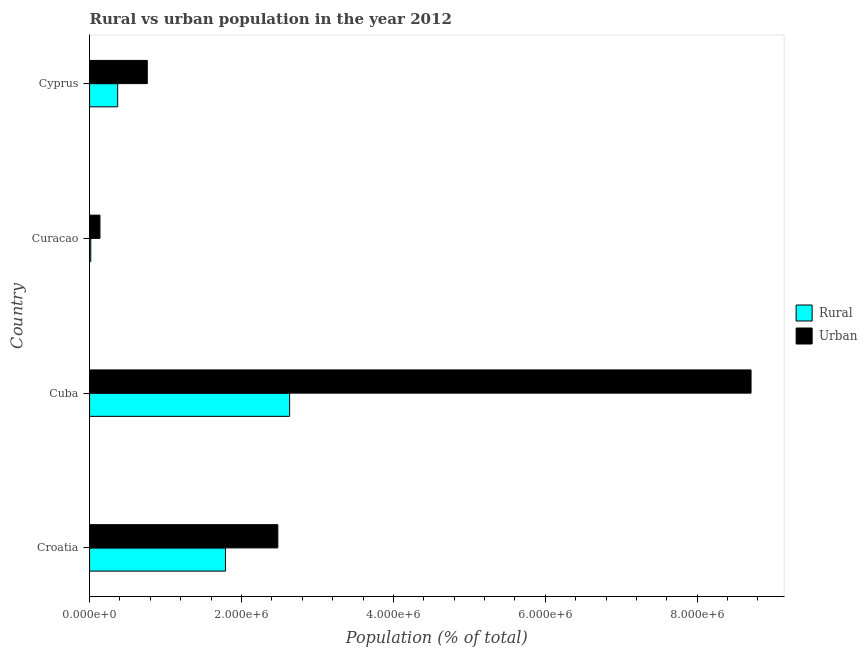Are the number of bars per tick equal to the number of legend labels?
Your response must be concise. Yes. How many bars are there on the 3rd tick from the bottom?
Give a very brief answer. 2. What is the label of the 4th group of bars from the top?
Provide a short and direct response. Croatia. In how many cases, is the number of bars for a given country not equal to the number of legend labels?
Make the answer very short. 0. What is the rural population density in Croatia?
Your answer should be compact. 1.79e+06. Across all countries, what is the maximum urban population density?
Keep it short and to the point. 8.71e+06. Across all countries, what is the minimum rural population density?
Give a very brief answer. 1.57e+04. In which country was the urban population density maximum?
Provide a succinct answer. Cuba. In which country was the rural population density minimum?
Provide a short and direct response. Curacao. What is the total rural population density in the graph?
Your response must be concise. 4.81e+06. What is the difference between the rural population density in Cuba and that in Cyprus?
Provide a short and direct response. 2.26e+06. What is the difference between the rural population density in Croatia and the urban population density in Cyprus?
Your answer should be compact. 1.03e+06. What is the average urban population density per country?
Your answer should be very brief. 3.02e+06. What is the difference between the rural population density and urban population density in Curacao?
Your answer should be compact. -1.21e+05. In how many countries, is the urban population density greater than 3600000 %?
Your response must be concise. 1. What is the ratio of the urban population density in Croatia to that in Cuba?
Make the answer very short. 0.28. What is the difference between the highest and the second highest rural population density?
Your response must be concise. 8.44e+05. What is the difference between the highest and the lowest rural population density?
Provide a succinct answer. 2.62e+06. In how many countries, is the urban population density greater than the average urban population density taken over all countries?
Offer a terse response. 1. Is the sum of the rural population density in Croatia and Cyprus greater than the maximum urban population density across all countries?
Make the answer very short. No. What does the 2nd bar from the top in Croatia represents?
Provide a short and direct response. Rural. What does the 2nd bar from the bottom in Cyprus represents?
Ensure brevity in your answer.  Urban. What is the difference between two consecutive major ticks on the X-axis?
Keep it short and to the point. 2.00e+06. Are the values on the major ticks of X-axis written in scientific E-notation?
Offer a terse response. Yes. Does the graph contain any zero values?
Your response must be concise. No. Does the graph contain grids?
Make the answer very short. No. Where does the legend appear in the graph?
Provide a short and direct response. Center right. What is the title of the graph?
Provide a short and direct response. Rural vs urban population in the year 2012. Does "Primary education" appear as one of the legend labels in the graph?
Provide a succinct answer. No. What is the label or title of the X-axis?
Give a very brief answer. Population (% of total). What is the label or title of the Y-axis?
Ensure brevity in your answer.  Country. What is the Population (% of total) in Rural in Croatia?
Give a very brief answer. 1.79e+06. What is the Population (% of total) in Urban in Croatia?
Provide a succinct answer. 2.48e+06. What is the Population (% of total) in Rural in Cuba?
Offer a very short reply. 2.63e+06. What is the Population (% of total) of Urban in Cuba?
Offer a terse response. 8.71e+06. What is the Population (% of total) of Rural in Curacao?
Provide a succinct answer. 1.57e+04. What is the Population (% of total) of Urban in Curacao?
Offer a very short reply. 1.36e+05. What is the Population (% of total) of Rural in Cyprus?
Provide a short and direct response. 3.70e+05. What is the Population (% of total) in Urban in Cyprus?
Ensure brevity in your answer.  7.60e+05. Across all countries, what is the maximum Population (% of total) of Rural?
Your response must be concise. 2.63e+06. Across all countries, what is the maximum Population (% of total) in Urban?
Make the answer very short. 8.71e+06. Across all countries, what is the minimum Population (% of total) in Rural?
Ensure brevity in your answer.  1.57e+04. Across all countries, what is the minimum Population (% of total) of Urban?
Keep it short and to the point. 1.36e+05. What is the total Population (% of total) of Rural in the graph?
Offer a very short reply. 4.81e+06. What is the total Population (% of total) of Urban in the graph?
Offer a terse response. 1.21e+07. What is the difference between the Population (% of total) in Rural in Croatia and that in Cuba?
Provide a short and direct response. -8.44e+05. What is the difference between the Population (% of total) in Urban in Croatia and that in Cuba?
Provide a short and direct response. -6.23e+06. What is the difference between the Population (% of total) of Rural in Croatia and that in Curacao?
Give a very brief answer. 1.77e+06. What is the difference between the Population (% of total) of Urban in Croatia and that in Curacao?
Give a very brief answer. 2.34e+06. What is the difference between the Population (% of total) in Rural in Croatia and that in Cyprus?
Your response must be concise. 1.42e+06. What is the difference between the Population (% of total) of Urban in Croatia and that in Cyprus?
Offer a terse response. 1.72e+06. What is the difference between the Population (% of total) in Rural in Cuba and that in Curacao?
Offer a terse response. 2.62e+06. What is the difference between the Population (% of total) of Urban in Cuba and that in Curacao?
Provide a short and direct response. 8.57e+06. What is the difference between the Population (% of total) of Rural in Cuba and that in Cyprus?
Give a very brief answer. 2.26e+06. What is the difference between the Population (% of total) in Urban in Cuba and that in Cyprus?
Keep it short and to the point. 7.95e+06. What is the difference between the Population (% of total) in Rural in Curacao and that in Cyprus?
Offer a terse response. -3.54e+05. What is the difference between the Population (% of total) of Urban in Curacao and that in Cyprus?
Your response must be concise. -6.23e+05. What is the difference between the Population (% of total) of Rural in Croatia and the Population (% of total) of Urban in Cuba?
Keep it short and to the point. -6.92e+06. What is the difference between the Population (% of total) in Rural in Croatia and the Population (% of total) in Urban in Curacao?
Make the answer very short. 1.65e+06. What is the difference between the Population (% of total) of Rural in Croatia and the Population (% of total) of Urban in Cyprus?
Provide a succinct answer. 1.03e+06. What is the difference between the Population (% of total) of Rural in Cuba and the Population (% of total) of Urban in Curacao?
Make the answer very short. 2.50e+06. What is the difference between the Population (% of total) in Rural in Cuba and the Population (% of total) in Urban in Cyprus?
Provide a succinct answer. 1.87e+06. What is the difference between the Population (% of total) in Rural in Curacao and the Population (% of total) in Urban in Cyprus?
Offer a terse response. -7.44e+05. What is the average Population (% of total) in Rural per country?
Your response must be concise. 1.20e+06. What is the average Population (% of total) of Urban per country?
Your answer should be very brief. 3.02e+06. What is the difference between the Population (% of total) of Rural and Population (% of total) of Urban in Croatia?
Give a very brief answer. -6.89e+05. What is the difference between the Population (% of total) in Rural and Population (% of total) in Urban in Cuba?
Your answer should be very brief. -6.08e+06. What is the difference between the Population (% of total) of Rural and Population (% of total) of Urban in Curacao?
Provide a short and direct response. -1.21e+05. What is the difference between the Population (% of total) in Rural and Population (% of total) in Urban in Cyprus?
Ensure brevity in your answer.  -3.90e+05. What is the ratio of the Population (% of total) in Rural in Croatia to that in Cuba?
Ensure brevity in your answer.  0.68. What is the ratio of the Population (% of total) of Urban in Croatia to that in Cuba?
Offer a terse response. 0.28. What is the ratio of the Population (% of total) of Rural in Croatia to that in Curacao?
Provide a short and direct response. 113.69. What is the ratio of the Population (% of total) of Urban in Croatia to that in Curacao?
Provide a short and direct response. 18.18. What is the ratio of the Population (% of total) of Rural in Croatia to that in Cyprus?
Provide a succinct answer. 4.84. What is the ratio of the Population (% of total) in Urban in Croatia to that in Cyprus?
Your answer should be compact. 3.26. What is the ratio of the Population (% of total) of Rural in Cuba to that in Curacao?
Your answer should be very brief. 167.34. What is the ratio of the Population (% of total) in Urban in Cuba to that in Curacao?
Your response must be concise. 63.87. What is the ratio of the Population (% of total) of Rural in Cuba to that in Cyprus?
Provide a short and direct response. 7.12. What is the ratio of the Population (% of total) of Urban in Cuba to that in Cyprus?
Offer a terse response. 11.47. What is the ratio of the Population (% of total) in Rural in Curacao to that in Cyprus?
Keep it short and to the point. 0.04. What is the ratio of the Population (% of total) in Urban in Curacao to that in Cyprus?
Your response must be concise. 0.18. What is the difference between the highest and the second highest Population (% of total) in Rural?
Offer a terse response. 8.44e+05. What is the difference between the highest and the second highest Population (% of total) of Urban?
Your response must be concise. 6.23e+06. What is the difference between the highest and the lowest Population (% of total) of Rural?
Offer a very short reply. 2.62e+06. What is the difference between the highest and the lowest Population (% of total) of Urban?
Keep it short and to the point. 8.57e+06. 